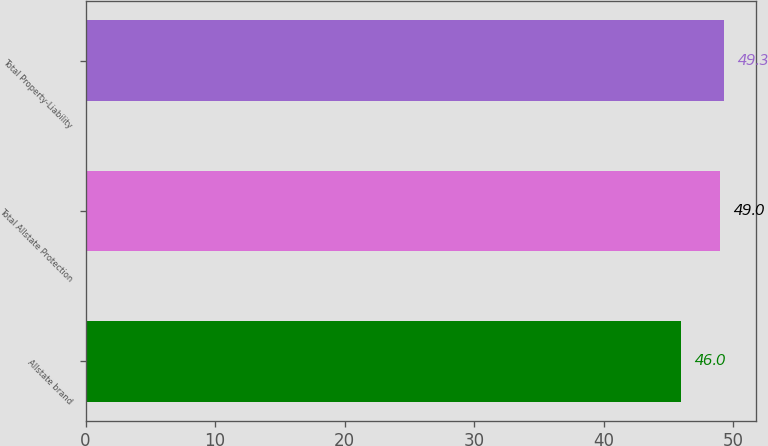<chart> <loc_0><loc_0><loc_500><loc_500><bar_chart><fcel>Allstate brand<fcel>Total Allstate Protection<fcel>Total Property-Liability<nl><fcel>46<fcel>49<fcel>49.3<nl></chart> 